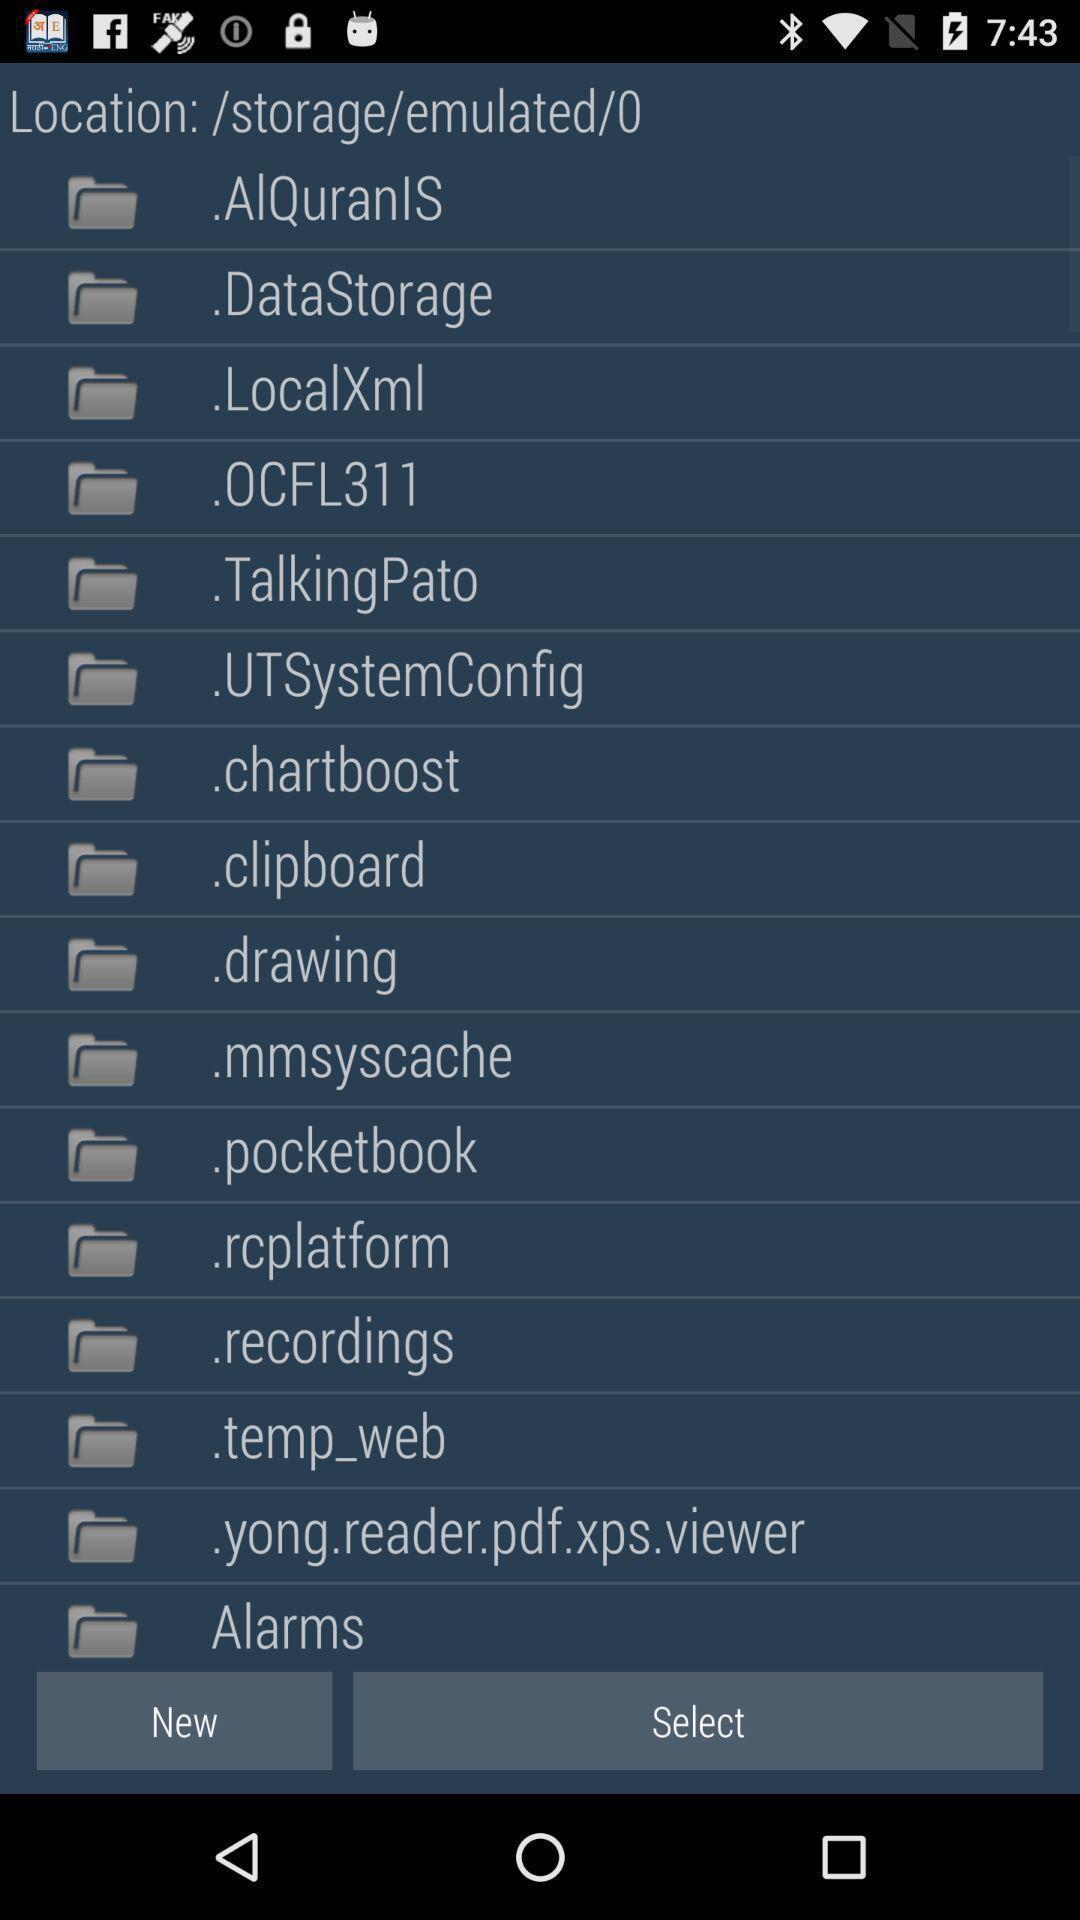Describe the key features of this screenshot. Page displaying various folders. 